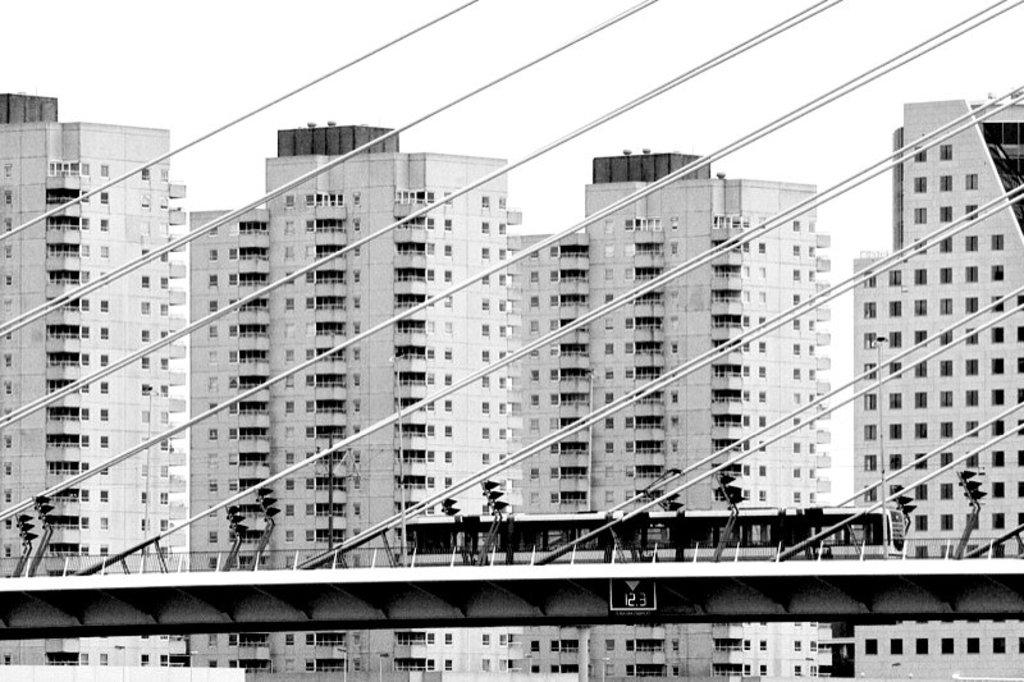What structure can be seen in the image? There is a bridge in the image. What is on the bridge? A locomotive is on the bridge. Is the locomotive stationary or moving? The locomotive is moving. What can be seen in the background of the image? There are buildings and a clear sky in the background of the image. How many brains can be seen in the image? There are no brains visible in the image; the image features a bridge, a locomotive, buildings, and a clear sky. What type of feet are visible on the locomotive in the image? There are no feet visible on the locomotive or any other part of the image. 